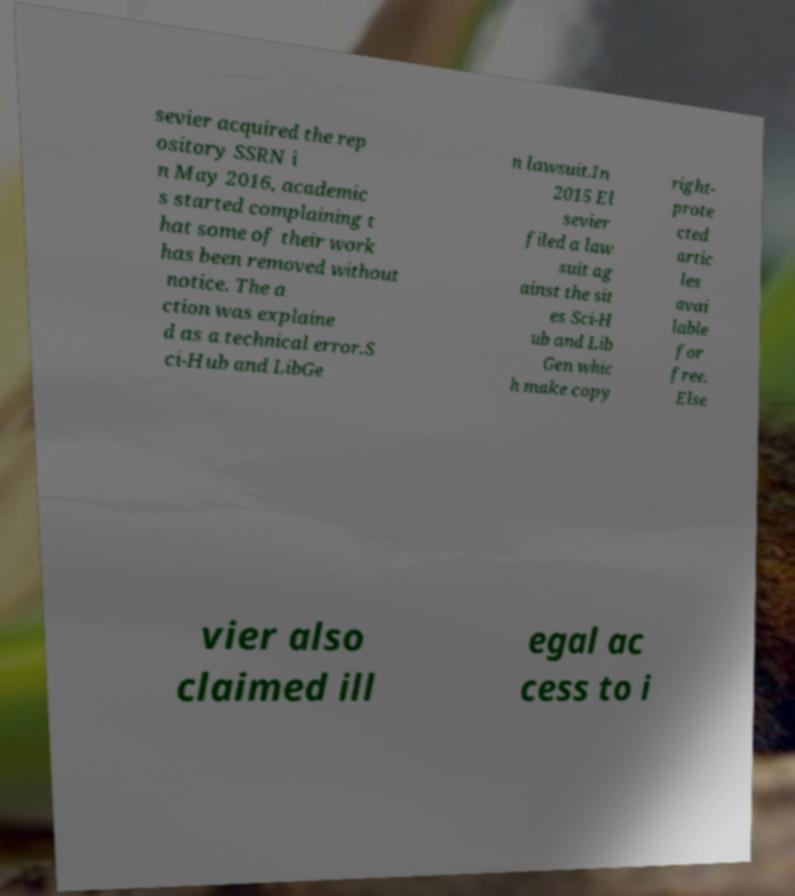Can you accurately transcribe the text from the provided image for me? sevier acquired the rep ository SSRN i n May 2016, academic s started complaining t hat some of their work has been removed without notice. The a ction was explaine d as a technical error.S ci-Hub and LibGe n lawsuit.In 2015 El sevier filed a law suit ag ainst the sit es Sci-H ub and Lib Gen whic h make copy right- prote cted artic les avai lable for free. Else vier also claimed ill egal ac cess to i 